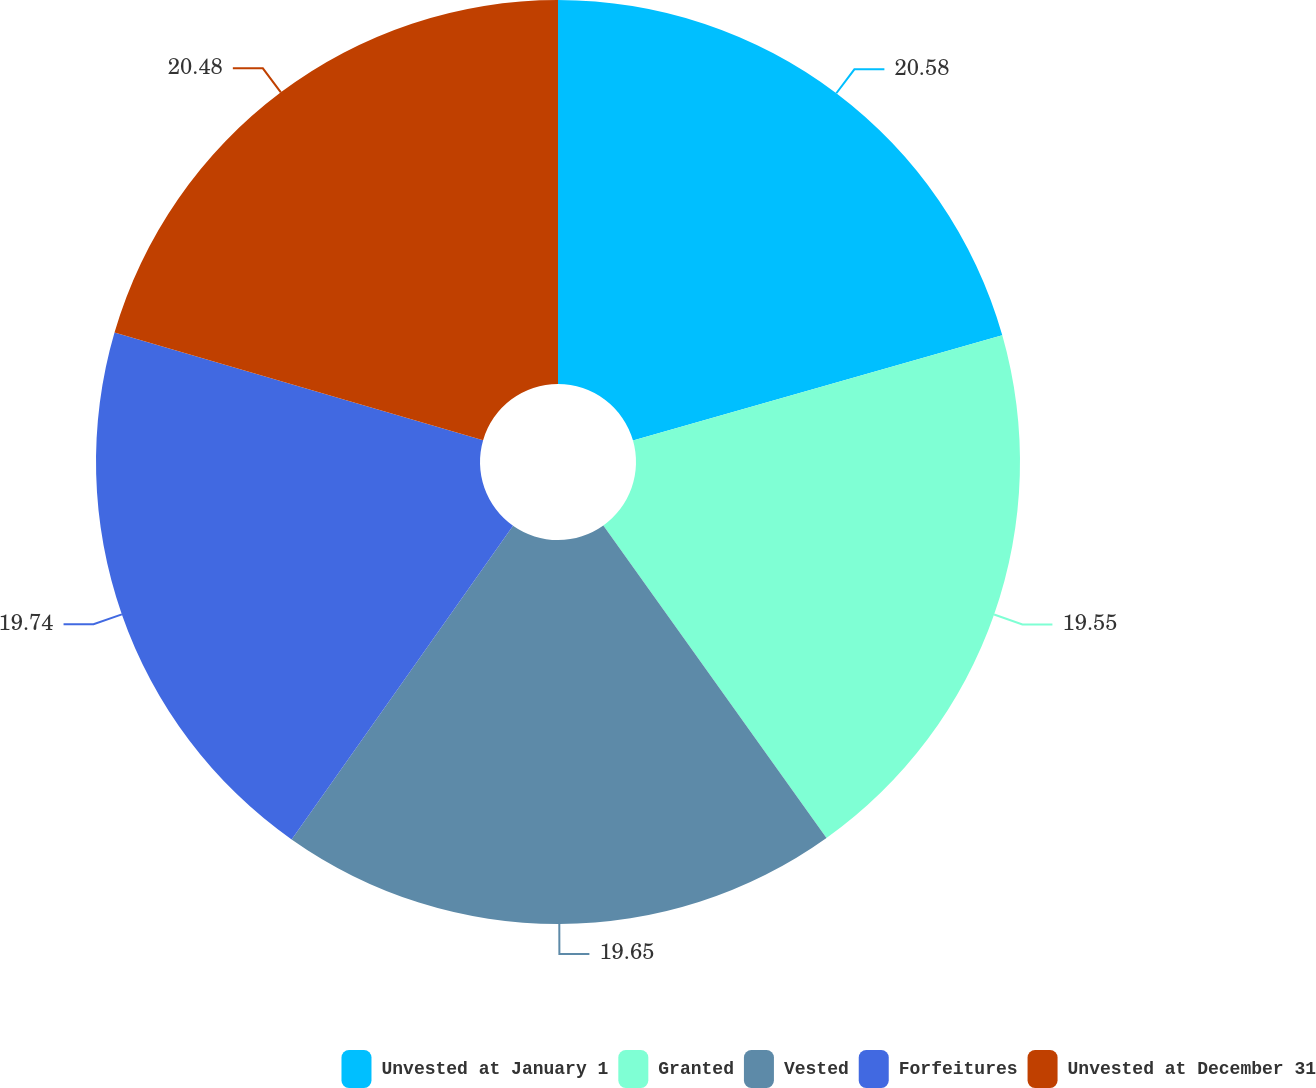<chart> <loc_0><loc_0><loc_500><loc_500><pie_chart><fcel>Unvested at January 1<fcel>Granted<fcel>Vested<fcel>Forfeitures<fcel>Unvested at December 31<nl><fcel>20.58%<fcel>19.55%<fcel>19.65%<fcel>19.74%<fcel>20.48%<nl></chart> 